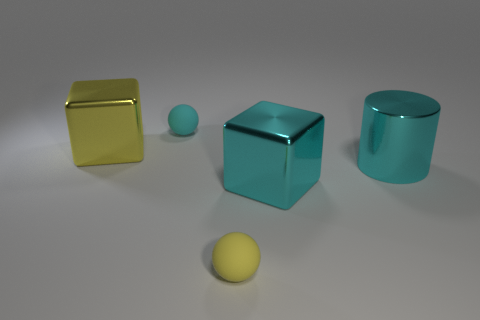Is there another shiny cylinder of the same color as the metallic cylinder?
Give a very brief answer. No. How many matte balls have the same color as the big cylinder?
Provide a succinct answer. 1. Does the shiny cylinder have the same color as the cube that is to the left of the yellow ball?
Keep it short and to the point. No. What number of objects are either big cyan cubes or tiny matte objects behind the yellow matte sphere?
Provide a short and direct response. 2. How big is the cube in front of the large thing that is behind the metallic cylinder?
Your response must be concise. Large. Are there the same number of small cyan balls that are on the right side of the yellow rubber thing and cyan shiny things that are in front of the large cyan metal cube?
Keep it short and to the point. Yes. Are there any big metallic things that are left of the thing behind the big yellow cube?
Keep it short and to the point. Yes. What is the shape of the object that is the same material as the tiny yellow sphere?
Provide a succinct answer. Sphere. Is there anything else that is the same color as the shiny cylinder?
Make the answer very short. Yes. There is a block to the left of the large metallic block that is to the right of the small yellow object; what is its material?
Provide a succinct answer. Metal. 